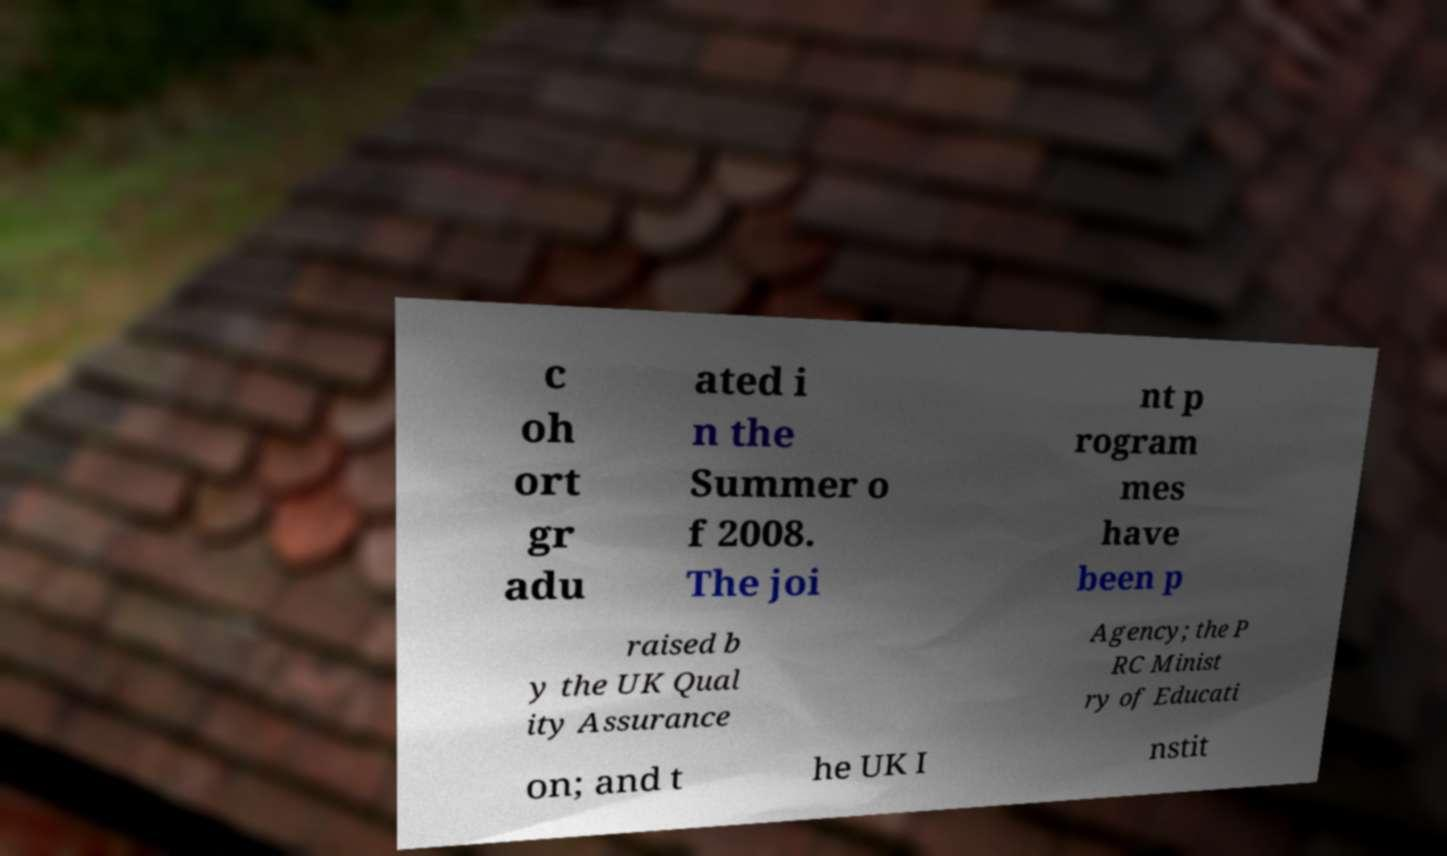Could you assist in decoding the text presented in this image and type it out clearly? c oh ort gr adu ated i n the Summer o f 2008. The joi nt p rogram mes have been p raised b y the UK Qual ity Assurance Agency; the P RC Minist ry of Educati on; and t he UK I nstit 